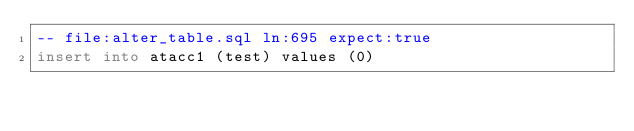Convert code to text. <code><loc_0><loc_0><loc_500><loc_500><_SQL_>-- file:alter_table.sql ln:695 expect:true
insert into atacc1 (test) values (0)
</code> 